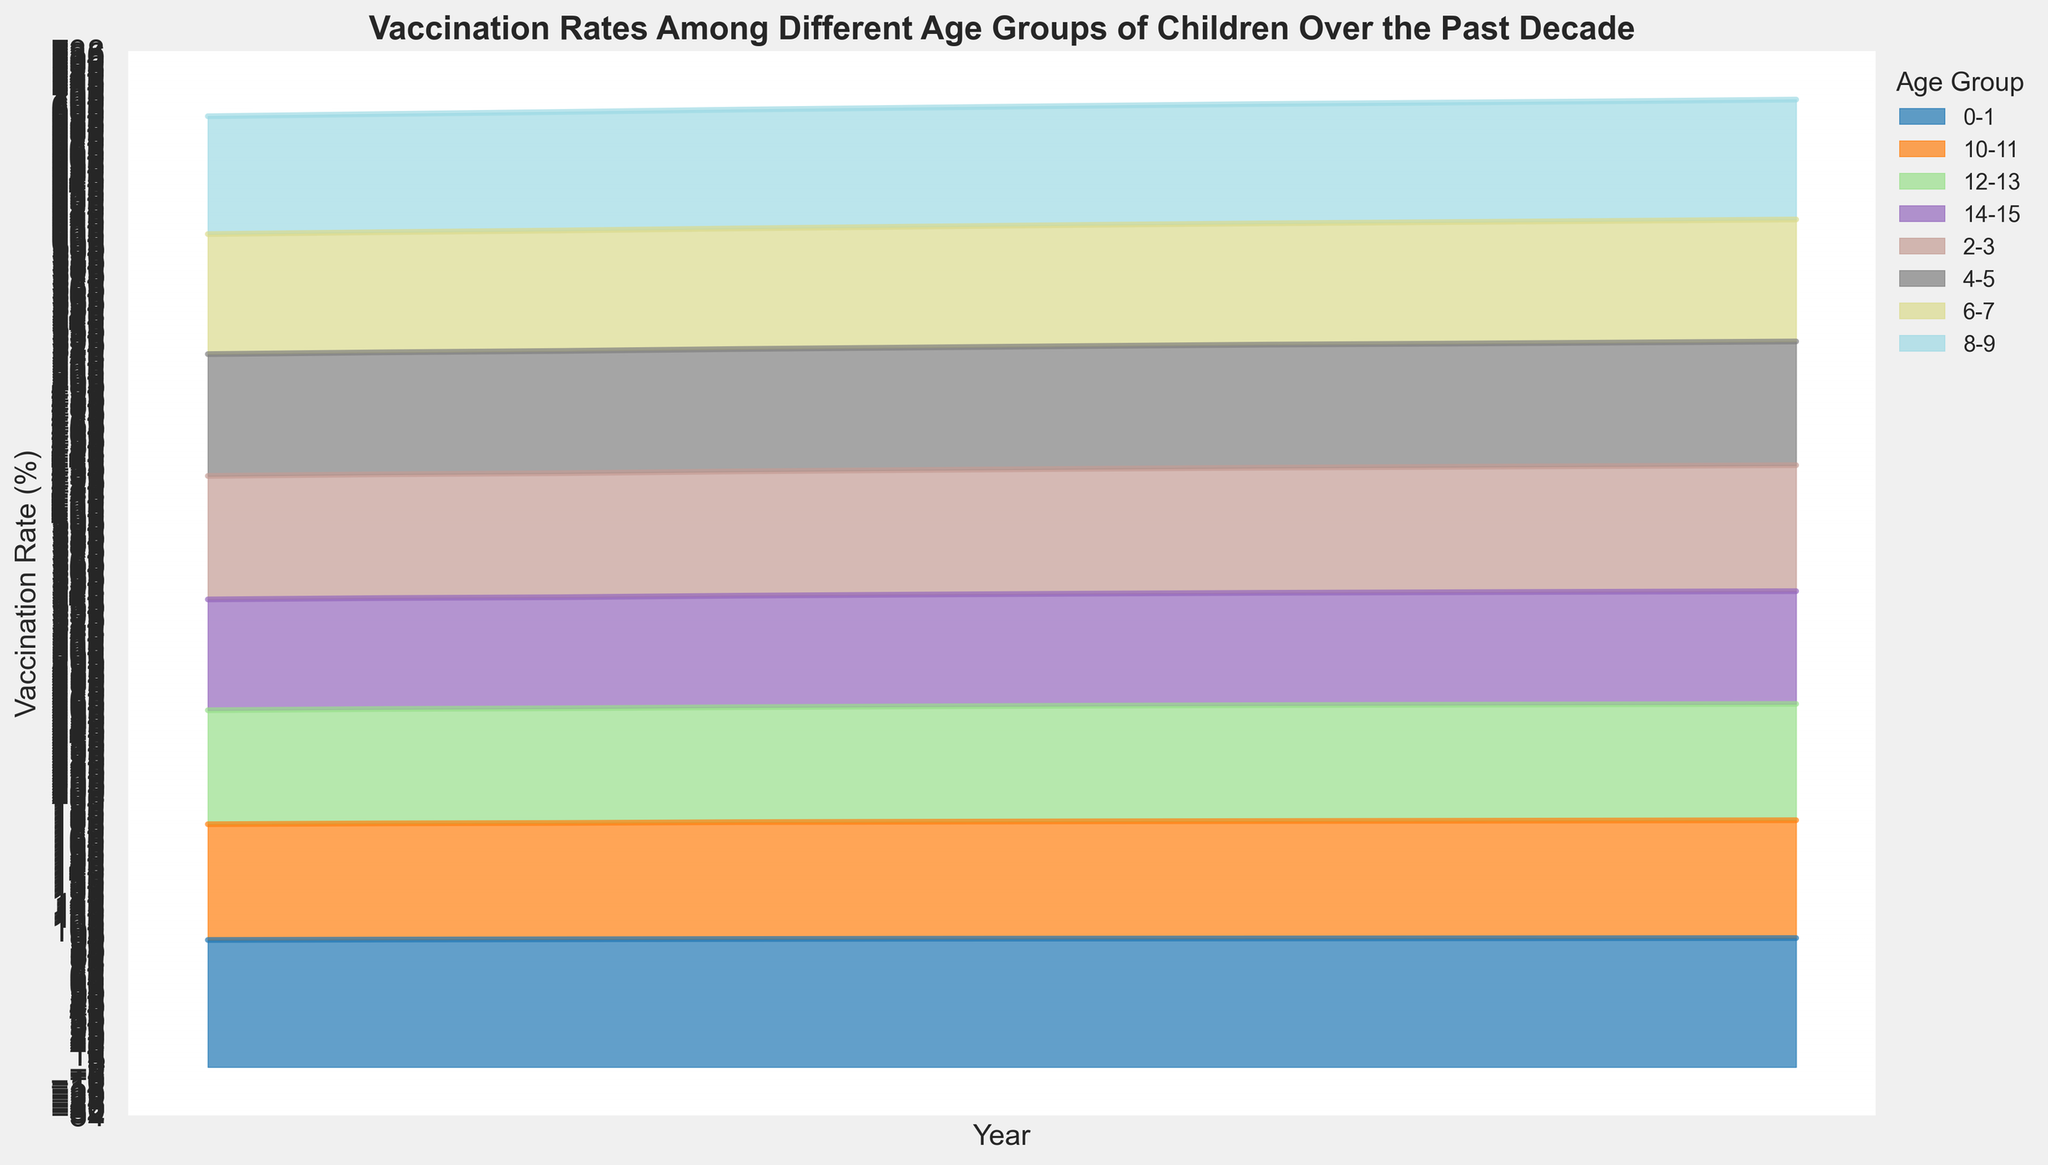Which age group has the highest vaccination rate in 2022? According to the figure, the age group with the highest percentage of vaccination rate is easy to see. Refer to the top section where the highest line segment per year is shown. For 2022, this is in the dark blue section, representing the 0-1 age group.
Answer: 0-1 How did the vaccination rate for the age group 4-5 change between 2013 and 2022? To determine the change, look at the initial and final values over the given time period for the 4-5 age group whose color is consistent throughout the chart. In 2013, the rate is 88.5%, and in 2022, it's 89.9%. Subtract the 2013 value from the 2022 value to find the change: 89.9 - 88.5 = 1.4
Answer: Increased by 1.4% Overall, did older age groups generally show lower vaccination rates compared to younger age groups? When examining the figure, note the stacking of areas. The lower sections represent younger age groups, and the higher ones represent older age groups. Older age groups such as 12-13 and 14-15 are consistently represented on top and show lower vaccination rates overall than the younger groups who are at the bottom.
Answer: Yes Compare the trend of the vaccination rate for the 2-3 and 14-15 age groups from 2013 to 2022. Which group shows a larger absolute increase? First, find the difference in vaccination rates from 2013 to 2022 for both groups. The 2-3 age group goes from 89.7% to 91.5%, an increase of 91.5 - 89.7 = 1.8. The 14-15 age group goes from 80.5% to 81.9%, an increase of 81.9 - 80.5 = 1.4. Hence, the 2-3 age group shows a larger absolute increase.
Answer: The 2-3 age group In what year did the 0-1 age group first surpass a vaccination rate of 93%? Look at the figure and find the point where the dark blue section crosses the 93% line in relation to the x-axis. The 0-1 age group first surpasses 93% in the year 2016 where the value is 93.1%.
Answer: 2016 What is the average annual increase in the vaccination rate for the 2-3 age group from 2013 to 2022? Calculation involves the difference in vaccination rates from 2022 to 2013, which is 91.5 - 89.7 = 1.8. Then divide by the number of years, which is 2022 - 2013 = 9. Therefore, the average annual increase is 1.8 / 9 = 0.2.
Answer: 0.2% per year Is the overall trend in vaccination rates upward or downward for most age groups between 2013 and 2022? To deduce the overall trend, observe whether the sections become wider or narrower over time. Most age groups' sections increase in width, indicating a rising trend.
Answer: Upward How does the trend for the 6-7 age group compare to the trend for the 10-11 age group? By comparing the middle sections of the chart, note the starting and ending values. The 6-7 age group rises from 87.2% to 88.6%, while the 10-11 age group follows a similar upward trajectory from 84.1% to 85.6%. Both trends are upward but the increase for 6-7 is slightly larger.
Answer: Similar upward, with 6-7 having a slightly larger increase 